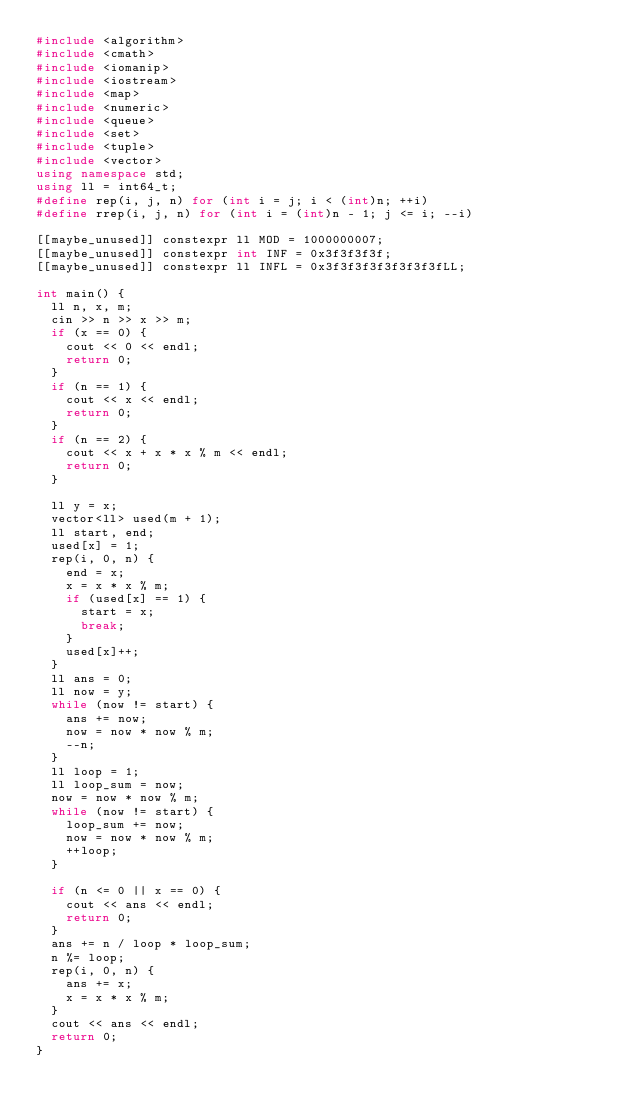Convert code to text. <code><loc_0><loc_0><loc_500><loc_500><_C++_>#include <algorithm>
#include <cmath>
#include <iomanip>
#include <iostream>
#include <map>
#include <numeric>
#include <queue>
#include <set>
#include <tuple>
#include <vector>
using namespace std;
using ll = int64_t;
#define rep(i, j, n) for (int i = j; i < (int)n; ++i)
#define rrep(i, j, n) for (int i = (int)n - 1; j <= i; --i)

[[maybe_unused]] constexpr ll MOD = 1000000007;
[[maybe_unused]] constexpr int INF = 0x3f3f3f3f;
[[maybe_unused]] constexpr ll INFL = 0x3f3f3f3f3f3f3f3fLL;

int main() {
  ll n, x, m;
  cin >> n >> x >> m;
  if (x == 0) {
    cout << 0 << endl;
    return 0;
  }
  if (n == 1) {
    cout << x << endl;
    return 0;
  }
  if (n == 2) {
    cout << x + x * x % m << endl;
    return 0;
  }

  ll y = x;
  vector<ll> used(m + 1);
  ll start, end;
  used[x] = 1;
  rep(i, 0, n) {
    end = x;
    x = x * x % m;
    if (used[x] == 1) {
      start = x;
      break;
    }
    used[x]++;
  }
  ll ans = 0;
  ll now = y;
  while (now != start) {
    ans += now;
    now = now * now % m;
    --n;
  }
  ll loop = 1;
  ll loop_sum = now;
  now = now * now % m;
  while (now != start) {
    loop_sum += now;
    now = now * now % m;
    ++loop;
  }

  if (n <= 0 || x == 0) {
    cout << ans << endl;
    return 0;
  }
  ans += n / loop * loop_sum;
  n %= loop;
  rep(i, 0, n) {
    ans += x;
    x = x * x % m;
  }
  cout << ans << endl;
  return 0;
}
</code> 